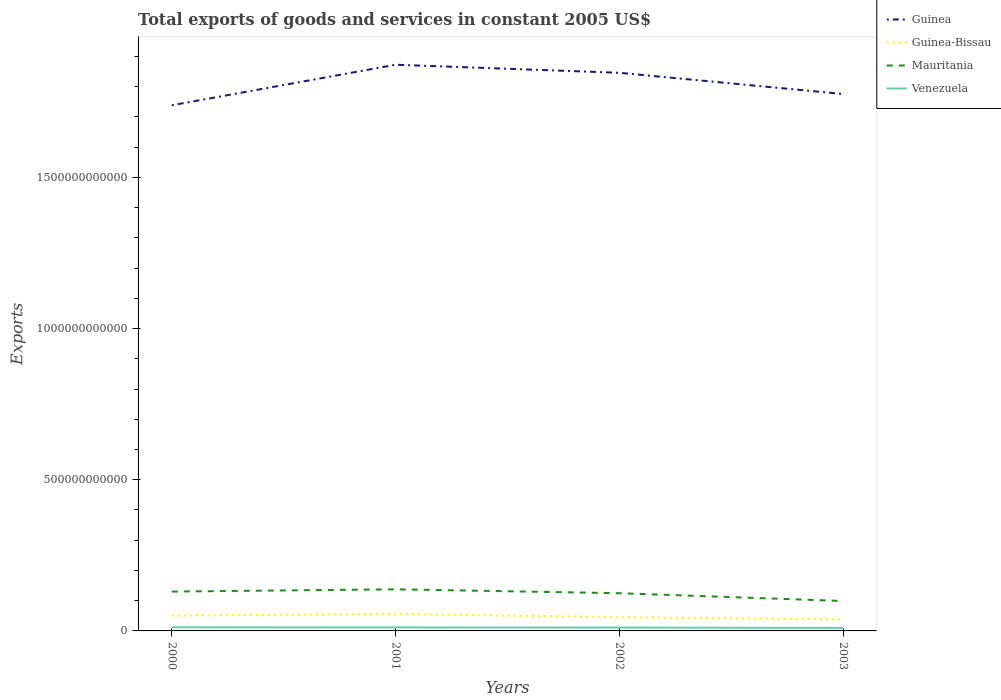Does the line corresponding to Mauritania intersect with the line corresponding to Guinea?
Your answer should be compact. No. Across all years, what is the maximum total exports of goods and services in Guinea?
Make the answer very short. 1.74e+12. In which year was the total exports of goods and services in Mauritania maximum?
Your answer should be very brief. 2003. What is the total total exports of goods and services in Venezuela in the graph?
Your response must be concise. 4.25e+08. What is the difference between the highest and the second highest total exports of goods and services in Guinea-Bissau?
Keep it short and to the point. 1.78e+1. What is the difference between the highest and the lowest total exports of goods and services in Guinea-Bissau?
Make the answer very short. 2. Is the total exports of goods and services in Guinea-Bissau strictly greater than the total exports of goods and services in Guinea over the years?
Provide a short and direct response. Yes. How many lines are there?
Give a very brief answer. 4. How many years are there in the graph?
Your answer should be compact. 4. What is the difference between two consecutive major ticks on the Y-axis?
Your response must be concise. 5.00e+11. Does the graph contain grids?
Keep it short and to the point. No. How are the legend labels stacked?
Make the answer very short. Vertical. What is the title of the graph?
Offer a terse response. Total exports of goods and services in constant 2005 US$. What is the label or title of the Y-axis?
Provide a short and direct response. Exports. What is the Exports in Guinea in 2000?
Offer a very short reply. 1.74e+12. What is the Exports in Guinea-Bissau in 2000?
Your response must be concise. 5.09e+1. What is the Exports in Mauritania in 2000?
Make the answer very short. 1.30e+11. What is the Exports of Venezuela in 2000?
Your answer should be compact. 1.20e+1. What is the Exports in Guinea in 2001?
Provide a short and direct response. 1.87e+12. What is the Exports in Guinea-Bissau in 2001?
Your answer should be compact. 5.61e+1. What is the Exports in Mauritania in 2001?
Your answer should be compact. 1.38e+11. What is the Exports in Venezuela in 2001?
Your response must be concise. 1.15e+1. What is the Exports in Guinea in 2002?
Your response must be concise. 1.85e+12. What is the Exports in Guinea-Bissau in 2002?
Provide a succinct answer. 4.53e+1. What is the Exports in Mauritania in 2002?
Provide a short and direct response. 1.25e+11. What is the Exports in Venezuela in 2002?
Your response must be concise. 1.11e+1. What is the Exports of Guinea in 2003?
Keep it short and to the point. 1.78e+12. What is the Exports of Guinea-Bissau in 2003?
Keep it short and to the point. 3.83e+1. What is the Exports in Mauritania in 2003?
Your answer should be compact. 9.89e+1. What is the Exports in Venezuela in 2003?
Your answer should be compact. 9.94e+09. Across all years, what is the maximum Exports of Guinea?
Your answer should be compact. 1.87e+12. Across all years, what is the maximum Exports in Guinea-Bissau?
Ensure brevity in your answer.  5.61e+1. Across all years, what is the maximum Exports in Mauritania?
Ensure brevity in your answer.  1.38e+11. Across all years, what is the maximum Exports in Venezuela?
Keep it short and to the point. 1.20e+1. Across all years, what is the minimum Exports in Guinea?
Offer a terse response. 1.74e+12. Across all years, what is the minimum Exports of Guinea-Bissau?
Your answer should be very brief. 3.83e+1. Across all years, what is the minimum Exports of Mauritania?
Offer a terse response. 9.89e+1. Across all years, what is the minimum Exports in Venezuela?
Provide a short and direct response. 9.94e+09. What is the total Exports in Guinea in the graph?
Keep it short and to the point. 7.23e+12. What is the total Exports of Guinea-Bissau in the graph?
Provide a succinct answer. 1.91e+11. What is the total Exports in Mauritania in the graph?
Provide a succinct answer. 4.91e+11. What is the total Exports in Venezuela in the graph?
Your response must be concise. 4.45e+1. What is the difference between the Exports in Guinea in 2000 and that in 2001?
Offer a very short reply. -1.34e+11. What is the difference between the Exports in Guinea-Bissau in 2000 and that in 2001?
Keep it short and to the point. -5.21e+09. What is the difference between the Exports of Mauritania in 2000 and that in 2001?
Give a very brief answer. -7.55e+09. What is the difference between the Exports in Venezuela in 2000 and that in 2001?
Your answer should be compact. 4.25e+08. What is the difference between the Exports in Guinea in 2000 and that in 2002?
Give a very brief answer. -1.07e+11. What is the difference between the Exports in Guinea-Bissau in 2000 and that in 2002?
Your answer should be very brief. 5.58e+09. What is the difference between the Exports in Mauritania in 2000 and that in 2002?
Your answer should be very brief. 5.41e+09. What is the difference between the Exports of Venezuela in 2000 and that in 2002?
Make the answer very short. 8.82e+08. What is the difference between the Exports of Guinea in 2000 and that in 2003?
Provide a short and direct response. -3.73e+1. What is the difference between the Exports in Guinea-Bissau in 2000 and that in 2003?
Keep it short and to the point. 1.26e+1. What is the difference between the Exports of Mauritania in 2000 and that in 2003?
Give a very brief answer. 3.12e+1. What is the difference between the Exports of Venezuela in 2000 and that in 2003?
Ensure brevity in your answer.  2.03e+09. What is the difference between the Exports of Guinea in 2001 and that in 2002?
Make the answer very short. 2.67e+1. What is the difference between the Exports in Guinea-Bissau in 2001 and that in 2002?
Offer a terse response. 1.08e+1. What is the difference between the Exports of Mauritania in 2001 and that in 2002?
Make the answer very short. 1.30e+1. What is the difference between the Exports of Venezuela in 2001 and that in 2002?
Offer a terse response. 4.57e+08. What is the difference between the Exports of Guinea in 2001 and that in 2003?
Offer a very short reply. 9.68e+1. What is the difference between the Exports in Guinea-Bissau in 2001 and that in 2003?
Keep it short and to the point. 1.78e+1. What is the difference between the Exports in Mauritania in 2001 and that in 2003?
Your response must be concise. 3.87e+1. What is the difference between the Exports of Venezuela in 2001 and that in 2003?
Your response must be concise. 1.61e+09. What is the difference between the Exports of Guinea in 2002 and that in 2003?
Your answer should be compact. 7.02e+1. What is the difference between the Exports in Guinea-Bissau in 2002 and that in 2003?
Your answer should be very brief. 7.01e+09. What is the difference between the Exports in Mauritania in 2002 and that in 2003?
Offer a terse response. 2.58e+1. What is the difference between the Exports of Venezuela in 2002 and that in 2003?
Offer a terse response. 1.15e+09. What is the difference between the Exports in Guinea in 2000 and the Exports in Guinea-Bissau in 2001?
Your response must be concise. 1.68e+12. What is the difference between the Exports of Guinea in 2000 and the Exports of Mauritania in 2001?
Offer a terse response. 1.60e+12. What is the difference between the Exports in Guinea in 2000 and the Exports in Venezuela in 2001?
Your response must be concise. 1.73e+12. What is the difference between the Exports in Guinea-Bissau in 2000 and the Exports in Mauritania in 2001?
Give a very brief answer. -8.67e+1. What is the difference between the Exports in Guinea-Bissau in 2000 and the Exports in Venezuela in 2001?
Your response must be concise. 3.94e+1. What is the difference between the Exports in Mauritania in 2000 and the Exports in Venezuela in 2001?
Provide a succinct answer. 1.19e+11. What is the difference between the Exports in Guinea in 2000 and the Exports in Guinea-Bissau in 2002?
Make the answer very short. 1.69e+12. What is the difference between the Exports in Guinea in 2000 and the Exports in Mauritania in 2002?
Your answer should be compact. 1.61e+12. What is the difference between the Exports in Guinea in 2000 and the Exports in Venezuela in 2002?
Your answer should be compact. 1.73e+12. What is the difference between the Exports in Guinea-Bissau in 2000 and the Exports in Mauritania in 2002?
Your answer should be very brief. -7.38e+1. What is the difference between the Exports in Guinea-Bissau in 2000 and the Exports in Venezuela in 2002?
Your response must be concise. 3.98e+1. What is the difference between the Exports of Mauritania in 2000 and the Exports of Venezuela in 2002?
Your answer should be very brief. 1.19e+11. What is the difference between the Exports in Guinea in 2000 and the Exports in Guinea-Bissau in 2003?
Offer a very short reply. 1.70e+12. What is the difference between the Exports of Guinea in 2000 and the Exports of Mauritania in 2003?
Keep it short and to the point. 1.64e+12. What is the difference between the Exports of Guinea in 2000 and the Exports of Venezuela in 2003?
Offer a terse response. 1.73e+12. What is the difference between the Exports of Guinea-Bissau in 2000 and the Exports of Mauritania in 2003?
Your response must be concise. -4.80e+1. What is the difference between the Exports of Guinea-Bissau in 2000 and the Exports of Venezuela in 2003?
Give a very brief answer. 4.10e+1. What is the difference between the Exports of Mauritania in 2000 and the Exports of Venezuela in 2003?
Offer a very short reply. 1.20e+11. What is the difference between the Exports in Guinea in 2001 and the Exports in Guinea-Bissau in 2002?
Keep it short and to the point. 1.83e+12. What is the difference between the Exports of Guinea in 2001 and the Exports of Mauritania in 2002?
Provide a short and direct response. 1.75e+12. What is the difference between the Exports of Guinea in 2001 and the Exports of Venezuela in 2002?
Make the answer very short. 1.86e+12. What is the difference between the Exports in Guinea-Bissau in 2001 and the Exports in Mauritania in 2002?
Provide a short and direct response. -6.86e+1. What is the difference between the Exports of Guinea-Bissau in 2001 and the Exports of Venezuela in 2002?
Your answer should be compact. 4.50e+1. What is the difference between the Exports in Mauritania in 2001 and the Exports in Venezuela in 2002?
Make the answer very short. 1.27e+11. What is the difference between the Exports of Guinea in 2001 and the Exports of Guinea-Bissau in 2003?
Provide a succinct answer. 1.83e+12. What is the difference between the Exports of Guinea in 2001 and the Exports of Mauritania in 2003?
Offer a very short reply. 1.77e+12. What is the difference between the Exports of Guinea in 2001 and the Exports of Venezuela in 2003?
Ensure brevity in your answer.  1.86e+12. What is the difference between the Exports of Guinea-Bissau in 2001 and the Exports of Mauritania in 2003?
Offer a terse response. -4.28e+1. What is the difference between the Exports of Guinea-Bissau in 2001 and the Exports of Venezuela in 2003?
Provide a short and direct response. 4.62e+1. What is the difference between the Exports of Mauritania in 2001 and the Exports of Venezuela in 2003?
Your answer should be compact. 1.28e+11. What is the difference between the Exports in Guinea in 2002 and the Exports in Guinea-Bissau in 2003?
Give a very brief answer. 1.81e+12. What is the difference between the Exports of Guinea in 2002 and the Exports of Mauritania in 2003?
Your answer should be very brief. 1.75e+12. What is the difference between the Exports in Guinea in 2002 and the Exports in Venezuela in 2003?
Give a very brief answer. 1.84e+12. What is the difference between the Exports in Guinea-Bissau in 2002 and the Exports in Mauritania in 2003?
Your response must be concise. -5.36e+1. What is the difference between the Exports of Guinea-Bissau in 2002 and the Exports of Venezuela in 2003?
Provide a short and direct response. 3.54e+1. What is the difference between the Exports of Mauritania in 2002 and the Exports of Venezuela in 2003?
Give a very brief answer. 1.15e+11. What is the average Exports in Guinea per year?
Give a very brief answer. 1.81e+12. What is the average Exports of Guinea-Bissau per year?
Offer a very short reply. 4.77e+1. What is the average Exports of Mauritania per year?
Offer a very short reply. 1.23e+11. What is the average Exports in Venezuela per year?
Make the answer very short. 1.11e+1. In the year 2000, what is the difference between the Exports in Guinea and Exports in Guinea-Bissau?
Keep it short and to the point. 1.69e+12. In the year 2000, what is the difference between the Exports in Guinea and Exports in Mauritania?
Your answer should be compact. 1.61e+12. In the year 2000, what is the difference between the Exports in Guinea and Exports in Venezuela?
Your answer should be very brief. 1.73e+12. In the year 2000, what is the difference between the Exports of Guinea-Bissau and Exports of Mauritania?
Provide a succinct answer. -7.92e+1. In the year 2000, what is the difference between the Exports in Guinea-Bissau and Exports in Venezuela?
Offer a terse response. 3.90e+1. In the year 2000, what is the difference between the Exports in Mauritania and Exports in Venezuela?
Provide a succinct answer. 1.18e+11. In the year 2001, what is the difference between the Exports of Guinea and Exports of Guinea-Bissau?
Provide a succinct answer. 1.82e+12. In the year 2001, what is the difference between the Exports in Guinea and Exports in Mauritania?
Your answer should be compact. 1.73e+12. In the year 2001, what is the difference between the Exports in Guinea and Exports in Venezuela?
Offer a terse response. 1.86e+12. In the year 2001, what is the difference between the Exports in Guinea-Bissau and Exports in Mauritania?
Give a very brief answer. -8.15e+1. In the year 2001, what is the difference between the Exports in Guinea-Bissau and Exports in Venezuela?
Make the answer very short. 4.46e+1. In the year 2001, what is the difference between the Exports in Mauritania and Exports in Venezuela?
Offer a terse response. 1.26e+11. In the year 2002, what is the difference between the Exports of Guinea and Exports of Guinea-Bissau?
Offer a terse response. 1.80e+12. In the year 2002, what is the difference between the Exports in Guinea and Exports in Mauritania?
Give a very brief answer. 1.72e+12. In the year 2002, what is the difference between the Exports of Guinea and Exports of Venezuela?
Provide a short and direct response. 1.83e+12. In the year 2002, what is the difference between the Exports in Guinea-Bissau and Exports in Mauritania?
Offer a terse response. -7.94e+1. In the year 2002, what is the difference between the Exports in Guinea-Bissau and Exports in Venezuela?
Keep it short and to the point. 3.43e+1. In the year 2002, what is the difference between the Exports of Mauritania and Exports of Venezuela?
Give a very brief answer. 1.14e+11. In the year 2003, what is the difference between the Exports of Guinea and Exports of Guinea-Bissau?
Give a very brief answer. 1.74e+12. In the year 2003, what is the difference between the Exports of Guinea and Exports of Mauritania?
Offer a terse response. 1.68e+12. In the year 2003, what is the difference between the Exports in Guinea and Exports in Venezuela?
Give a very brief answer. 1.77e+12. In the year 2003, what is the difference between the Exports of Guinea-Bissau and Exports of Mauritania?
Your answer should be very brief. -6.06e+1. In the year 2003, what is the difference between the Exports of Guinea-Bissau and Exports of Venezuela?
Keep it short and to the point. 2.84e+1. In the year 2003, what is the difference between the Exports in Mauritania and Exports in Venezuela?
Provide a succinct answer. 8.90e+1. What is the ratio of the Exports in Guinea in 2000 to that in 2001?
Offer a terse response. 0.93. What is the ratio of the Exports of Guinea-Bissau in 2000 to that in 2001?
Offer a very short reply. 0.91. What is the ratio of the Exports in Mauritania in 2000 to that in 2001?
Give a very brief answer. 0.95. What is the ratio of the Exports of Venezuela in 2000 to that in 2001?
Your answer should be very brief. 1.04. What is the ratio of the Exports of Guinea in 2000 to that in 2002?
Provide a succinct answer. 0.94. What is the ratio of the Exports in Guinea-Bissau in 2000 to that in 2002?
Provide a succinct answer. 1.12. What is the ratio of the Exports of Mauritania in 2000 to that in 2002?
Keep it short and to the point. 1.04. What is the ratio of the Exports in Venezuela in 2000 to that in 2002?
Give a very brief answer. 1.08. What is the ratio of the Exports of Guinea-Bissau in 2000 to that in 2003?
Give a very brief answer. 1.33. What is the ratio of the Exports in Mauritania in 2000 to that in 2003?
Make the answer very short. 1.32. What is the ratio of the Exports in Venezuela in 2000 to that in 2003?
Keep it short and to the point. 1.2. What is the ratio of the Exports in Guinea in 2001 to that in 2002?
Give a very brief answer. 1.01. What is the ratio of the Exports in Guinea-Bissau in 2001 to that in 2002?
Your response must be concise. 1.24. What is the ratio of the Exports of Mauritania in 2001 to that in 2002?
Your response must be concise. 1.1. What is the ratio of the Exports in Venezuela in 2001 to that in 2002?
Offer a very short reply. 1.04. What is the ratio of the Exports in Guinea in 2001 to that in 2003?
Give a very brief answer. 1.05. What is the ratio of the Exports in Guinea-Bissau in 2001 to that in 2003?
Your answer should be very brief. 1.46. What is the ratio of the Exports in Mauritania in 2001 to that in 2003?
Give a very brief answer. 1.39. What is the ratio of the Exports in Venezuela in 2001 to that in 2003?
Offer a terse response. 1.16. What is the ratio of the Exports in Guinea in 2002 to that in 2003?
Provide a short and direct response. 1.04. What is the ratio of the Exports of Guinea-Bissau in 2002 to that in 2003?
Ensure brevity in your answer.  1.18. What is the ratio of the Exports of Mauritania in 2002 to that in 2003?
Make the answer very short. 1.26. What is the ratio of the Exports in Venezuela in 2002 to that in 2003?
Provide a short and direct response. 1.12. What is the difference between the highest and the second highest Exports of Guinea?
Ensure brevity in your answer.  2.67e+1. What is the difference between the highest and the second highest Exports in Guinea-Bissau?
Ensure brevity in your answer.  5.21e+09. What is the difference between the highest and the second highest Exports of Mauritania?
Give a very brief answer. 7.55e+09. What is the difference between the highest and the second highest Exports in Venezuela?
Your answer should be very brief. 4.25e+08. What is the difference between the highest and the lowest Exports in Guinea?
Offer a terse response. 1.34e+11. What is the difference between the highest and the lowest Exports of Guinea-Bissau?
Your answer should be very brief. 1.78e+1. What is the difference between the highest and the lowest Exports in Mauritania?
Make the answer very short. 3.87e+1. What is the difference between the highest and the lowest Exports in Venezuela?
Provide a succinct answer. 2.03e+09. 